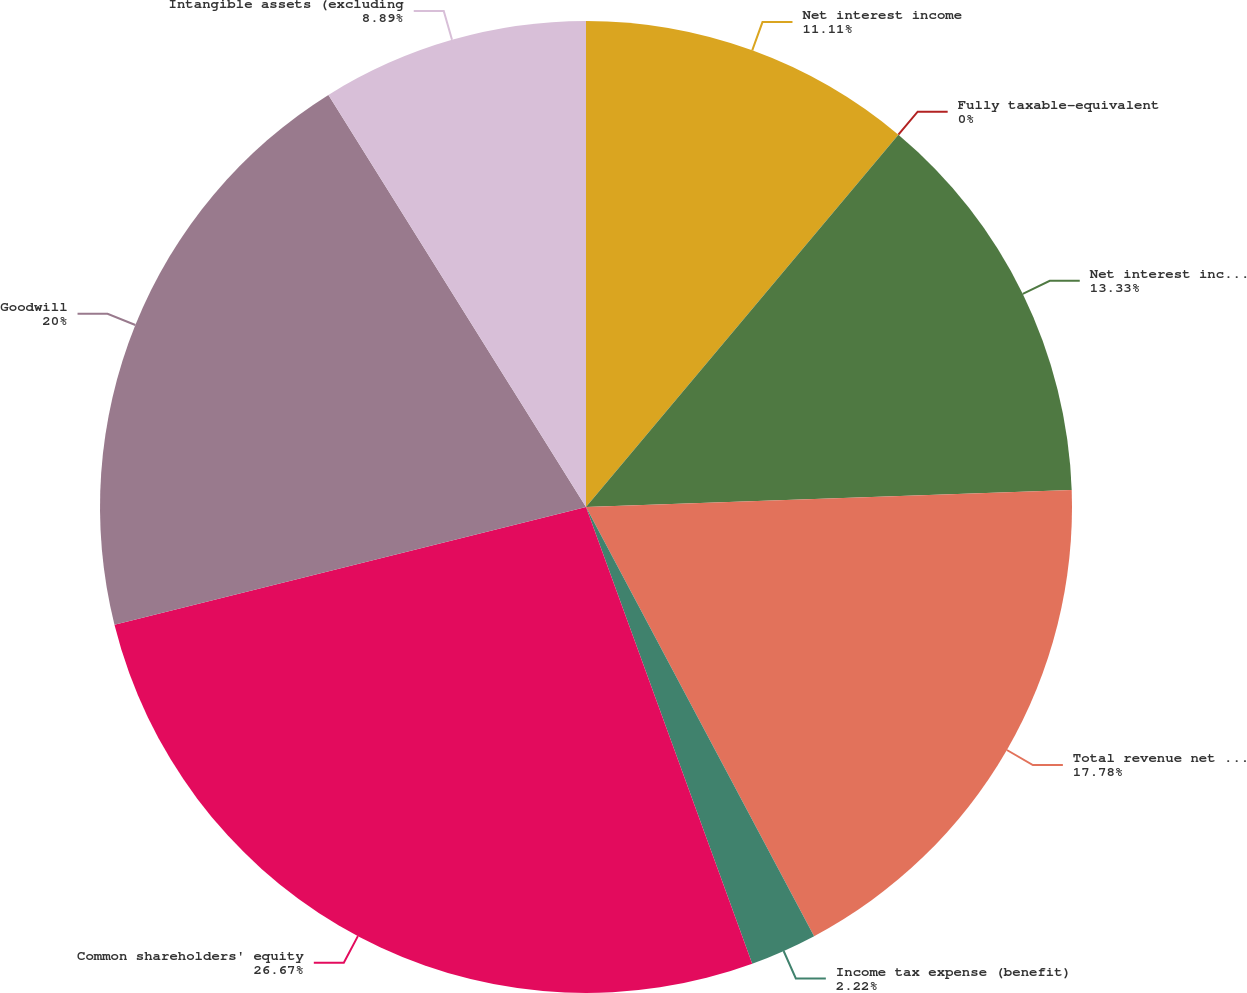<chart> <loc_0><loc_0><loc_500><loc_500><pie_chart><fcel>Net interest income<fcel>Fully taxable-equivalent<fcel>Net interest income on a fully<fcel>Total revenue net of interest<fcel>Income tax expense (benefit)<fcel>Common shareholders' equity<fcel>Goodwill<fcel>Intangible assets (excluding<nl><fcel>11.11%<fcel>0.0%<fcel>13.33%<fcel>17.78%<fcel>2.22%<fcel>26.66%<fcel>20.0%<fcel>8.89%<nl></chart> 